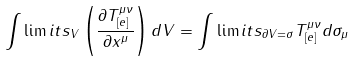<formula> <loc_0><loc_0><loc_500><loc_500>\int \lim i t s _ { V } \left ( \frac { \partial T _ { [ e ] } ^ { \mu \nu } } { \partial x ^ { \mu } } \right ) d V = \int \lim i t s _ { \partial V = \sigma } T _ { [ e ] } ^ { \mu \nu } d \sigma _ { \mu }</formula> 